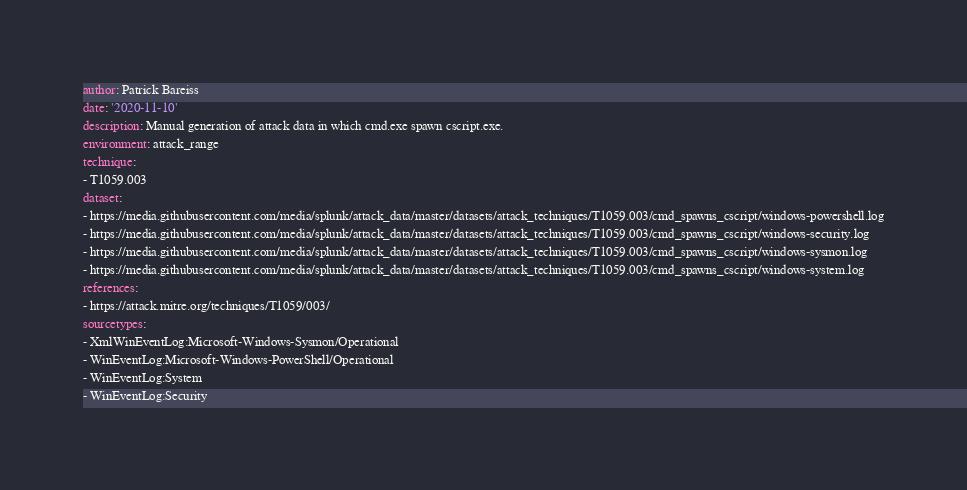<code> <loc_0><loc_0><loc_500><loc_500><_YAML_>author: Patrick Bareiss
date: '2020-11-10'
description: Manual generation of attack data in which cmd.exe spawn cscript.exe.
environment: attack_range
technique:
- T1059.003
dataset:
- https://media.githubusercontent.com/media/splunk/attack_data/master/datasets/attack_techniques/T1059.003/cmd_spawns_cscript/windows-powershell.log
- https://media.githubusercontent.com/media/splunk/attack_data/master/datasets/attack_techniques/T1059.003/cmd_spawns_cscript/windows-security.log
- https://media.githubusercontent.com/media/splunk/attack_data/master/datasets/attack_techniques/T1059.003/cmd_spawns_cscript/windows-sysmon.log
- https://media.githubusercontent.com/media/splunk/attack_data/master/datasets/attack_techniques/T1059.003/cmd_spawns_cscript/windows-system.log
references:
- https://attack.mitre.org/techniques/T1059/003/
sourcetypes:
- XmlWinEventLog:Microsoft-Windows-Sysmon/Operational
- WinEventLog:Microsoft-Windows-PowerShell/Operational
- WinEventLog:System
- WinEventLog:Security
</code> 